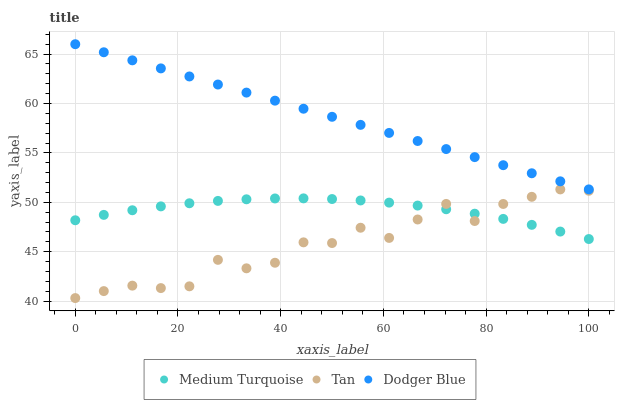Does Tan have the minimum area under the curve?
Answer yes or no. Yes. Does Dodger Blue have the maximum area under the curve?
Answer yes or no. Yes. Does Medium Turquoise have the minimum area under the curve?
Answer yes or no. No. Does Medium Turquoise have the maximum area under the curve?
Answer yes or no. No. Is Dodger Blue the smoothest?
Answer yes or no. Yes. Is Tan the roughest?
Answer yes or no. Yes. Is Medium Turquoise the smoothest?
Answer yes or no. No. Is Medium Turquoise the roughest?
Answer yes or no. No. Does Tan have the lowest value?
Answer yes or no. Yes. Does Medium Turquoise have the lowest value?
Answer yes or no. No. Does Dodger Blue have the highest value?
Answer yes or no. Yes. Does Medium Turquoise have the highest value?
Answer yes or no. No. Is Tan less than Dodger Blue?
Answer yes or no. Yes. Is Dodger Blue greater than Tan?
Answer yes or no. Yes. Does Medium Turquoise intersect Tan?
Answer yes or no. Yes. Is Medium Turquoise less than Tan?
Answer yes or no. No. Is Medium Turquoise greater than Tan?
Answer yes or no. No. Does Tan intersect Dodger Blue?
Answer yes or no. No. 